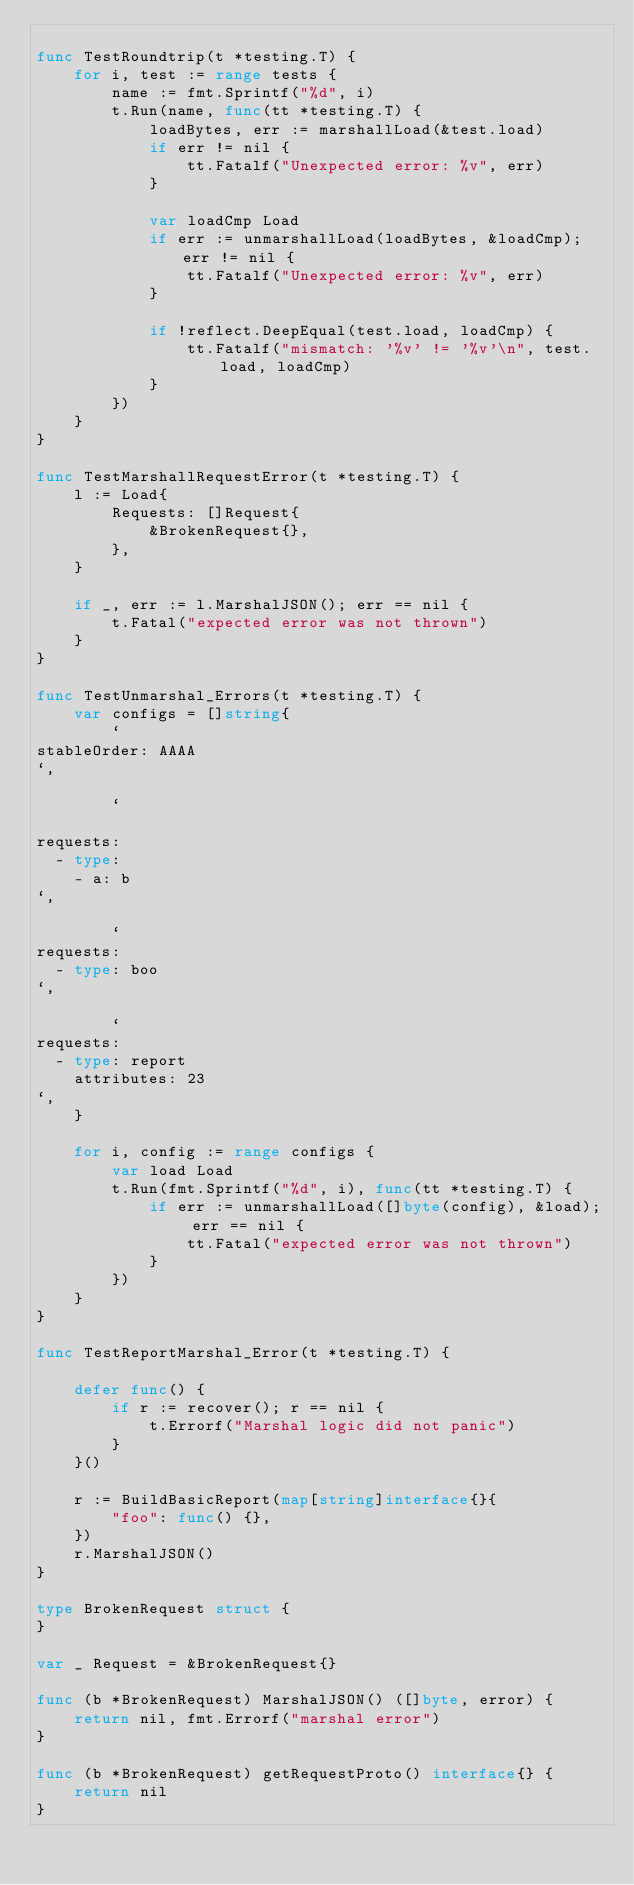Convert code to text. <code><loc_0><loc_0><loc_500><loc_500><_Go_>
func TestRoundtrip(t *testing.T) {
	for i, test := range tests {
		name := fmt.Sprintf("%d", i)
		t.Run(name, func(tt *testing.T) {
			loadBytes, err := marshallLoad(&test.load)
			if err != nil {
				tt.Fatalf("Unexpected error: %v", err)
			}

			var loadCmp Load
			if err := unmarshallLoad(loadBytes, &loadCmp); err != nil {
				tt.Fatalf("Unexpected error: %v", err)
			}

			if !reflect.DeepEqual(test.load, loadCmp) {
				tt.Fatalf("mismatch: '%v' != '%v'\n", test.load, loadCmp)
			}
		})
	}
}

func TestMarshallRequestError(t *testing.T) {
	l := Load{
		Requests: []Request{
			&BrokenRequest{},
		},
	}

	if _, err := l.MarshalJSON(); err == nil {
		t.Fatal("expected error was not thrown")
	}
}

func TestUnmarshal_Errors(t *testing.T) {
	var configs = []string{
		`
stableOrder: AAAA
`,

		`

requests:
  - type:
    - a: b
`,

		`
requests:
  - type: boo
`,

		`
requests:
  - type: report
    attributes: 23
`,
	}

	for i, config := range configs {
		var load Load
		t.Run(fmt.Sprintf("%d", i), func(tt *testing.T) {
			if err := unmarshallLoad([]byte(config), &load); err == nil {
				tt.Fatal("expected error was not thrown")
			}
		})
	}
}

func TestReportMarshal_Error(t *testing.T) {

	defer func() {
		if r := recover(); r == nil {
			t.Errorf("Marshal logic did not panic")
		}
	}()

	r := BuildBasicReport(map[string]interface{}{
		"foo": func() {},
	})
	r.MarshalJSON()
}

type BrokenRequest struct {
}

var _ Request = &BrokenRequest{}

func (b *BrokenRequest) MarshalJSON() ([]byte, error) {
	return nil, fmt.Errorf("marshal error")
}

func (b *BrokenRequest) getRequestProto() interface{} {
	return nil
}
</code> 